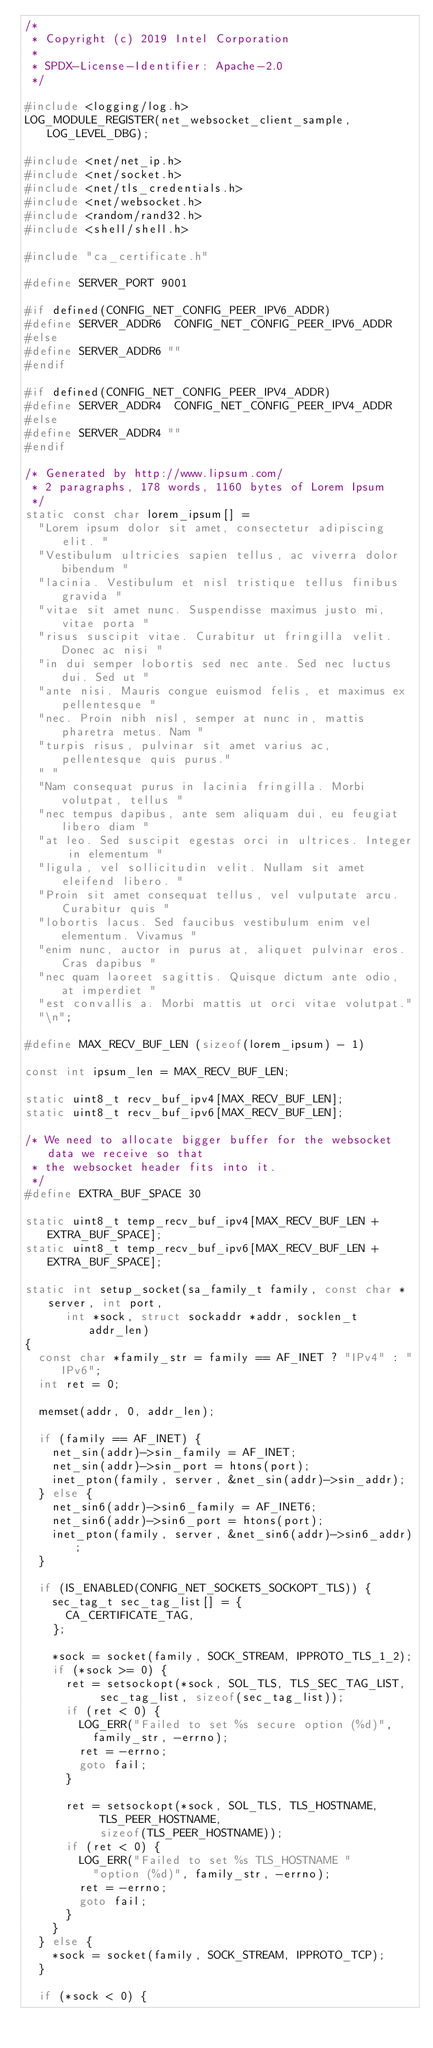Convert code to text. <code><loc_0><loc_0><loc_500><loc_500><_C_>/*
 * Copyright (c) 2019 Intel Corporation
 *
 * SPDX-License-Identifier: Apache-2.0
 */

#include <logging/log.h>
LOG_MODULE_REGISTER(net_websocket_client_sample, LOG_LEVEL_DBG);

#include <net/net_ip.h>
#include <net/socket.h>
#include <net/tls_credentials.h>
#include <net/websocket.h>
#include <random/rand32.h>
#include <shell/shell.h>

#include "ca_certificate.h"

#define SERVER_PORT 9001

#if defined(CONFIG_NET_CONFIG_PEER_IPV6_ADDR)
#define SERVER_ADDR6  CONFIG_NET_CONFIG_PEER_IPV6_ADDR
#else
#define SERVER_ADDR6 ""
#endif

#if defined(CONFIG_NET_CONFIG_PEER_IPV4_ADDR)
#define SERVER_ADDR4  CONFIG_NET_CONFIG_PEER_IPV4_ADDR
#else
#define SERVER_ADDR4 ""
#endif

/* Generated by http://www.lipsum.com/
 * 2 paragraphs, 178 words, 1160 bytes of Lorem Ipsum
 */
static const char lorem_ipsum[] =
	"Lorem ipsum dolor sit amet, consectetur adipiscing elit. "
	"Vestibulum ultricies sapien tellus, ac viverra dolor bibendum "
	"lacinia. Vestibulum et nisl tristique tellus finibus gravida "
	"vitae sit amet nunc. Suspendisse maximus justo mi, vitae porta "
	"risus suscipit vitae. Curabitur ut fringilla velit. Donec ac nisi "
	"in dui semper lobortis sed nec ante. Sed nec luctus dui. Sed ut "
	"ante nisi. Mauris congue euismod felis, et maximus ex pellentesque "
	"nec. Proin nibh nisl, semper at nunc in, mattis pharetra metus. Nam "
	"turpis risus, pulvinar sit amet varius ac, pellentesque quis purus."
	" "
	"Nam consequat purus in lacinia fringilla. Morbi volutpat, tellus "
	"nec tempus dapibus, ante sem aliquam dui, eu feugiat libero diam "
	"at leo. Sed suscipit egestas orci in ultrices. Integer in elementum "
	"ligula, vel sollicitudin velit. Nullam sit amet eleifend libero. "
	"Proin sit amet consequat tellus, vel vulputate arcu. Curabitur quis "
	"lobortis lacus. Sed faucibus vestibulum enim vel elementum. Vivamus "
	"enim nunc, auctor in purus at, aliquet pulvinar eros. Cras dapibus "
	"nec quam laoreet sagittis. Quisque dictum ante odio, at imperdiet "
	"est convallis a. Morbi mattis ut orci vitae volutpat."
	"\n";

#define MAX_RECV_BUF_LEN (sizeof(lorem_ipsum) - 1)

const int ipsum_len = MAX_RECV_BUF_LEN;

static uint8_t recv_buf_ipv4[MAX_RECV_BUF_LEN];
static uint8_t recv_buf_ipv6[MAX_RECV_BUF_LEN];

/* We need to allocate bigger buffer for the websocket data we receive so that
 * the websocket header fits into it.
 */
#define EXTRA_BUF_SPACE 30

static uint8_t temp_recv_buf_ipv4[MAX_RECV_BUF_LEN + EXTRA_BUF_SPACE];
static uint8_t temp_recv_buf_ipv6[MAX_RECV_BUF_LEN + EXTRA_BUF_SPACE];

static int setup_socket(sa_family_t family, const char *server, int port,
			int *sock, struct sockaddr *addr, socklen_t addr_len)
{
	const char *family_str = family == AF_INET ? "IPv4" : "IPv6";
	int ret = 0;

	memset(addr, 0, addr_len);

	if (family == AF_INET) {
		net_sin(addr)->sin_family = AF_INET;
		net_sin(addr)->sin_port = htons(port);
		inet_pton(family, server, &net_sin(addr)->sin_addr);
	} else {
		net_sin6(addr)->sin6_family = AF_INET6;
		net_sin6(addr)->sin6_port = htons(port);
		inet_pton(family, server, &net_sin6(addr)->sin6_addr);
	}

	if (IS_ENABLED(CONFIG_NET_SOCKETS_SOCKOPT_TLS)) {
		sec_tag_t sec_tag_list[] = {
			CA_CERTIFICATE_TAG,
		};

		*sock = socket(family, SOCK_STREAM, IPPROTO_TLS_1_2);
		if (*sock >= 0) {
			ret = setsockopt(*sock, SOL_TLS, TLS_SEC_TAG_LIST,
					 sec_tag_list, sizeof(sec_tag_list));
			if (ret < 0) {
				LOG_ERR("Failed to set %s secure option (%d)",
					family_str, -errno);
				ret = -errno;
				goto fail;
			}

			ret = setsockopt(*sock, SOL_TLS, TLS_HOSTNAME,
					 TLS_PEER_HOSTNAME,
					 sizeof(TLS_PEER_HOSTNAME));
			if (ret < 0) {
				LOG_ERR("Failed to set %s TLS_HOSTNAME "
					"option (%d)", family_str, -errno);
				ret = -errno;
				goto fail;
			}
		}
	} else {
		*sock = socket(family, SOCK_STREAM, IPPROTO_TCP);
	}

	if (*sock < 0) {</code> 